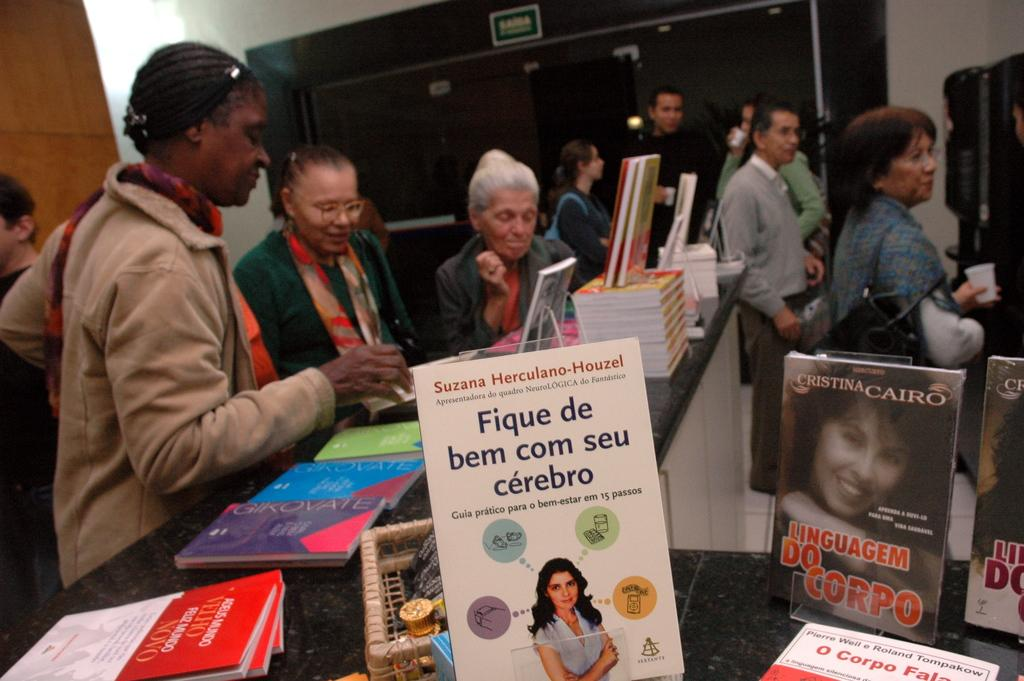Provide a one-sentence caption for the provided image. Many people at a book store looking at books in other languages. 